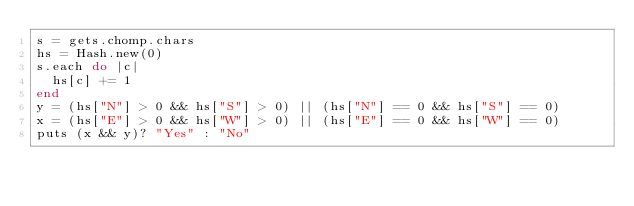Convert code to text. <code><loc_0><loc_0><loc_500><loc_500><_Ruby_>s = gets.chomp.chars
hs = Hash.new(0)
s.each do |c|
  hs[c] += 1
end
y = (hs["N"] > 0 && hs["S"] > 0) || (hs["N"] == 0 && hs["S"] == 0)
x = (hs["E"] > 0 && hs["W"] > 0) || (hs["E"] == 0 && hs["W"] == 0)
puts (x && y)? "Yes" : "No"</code> 